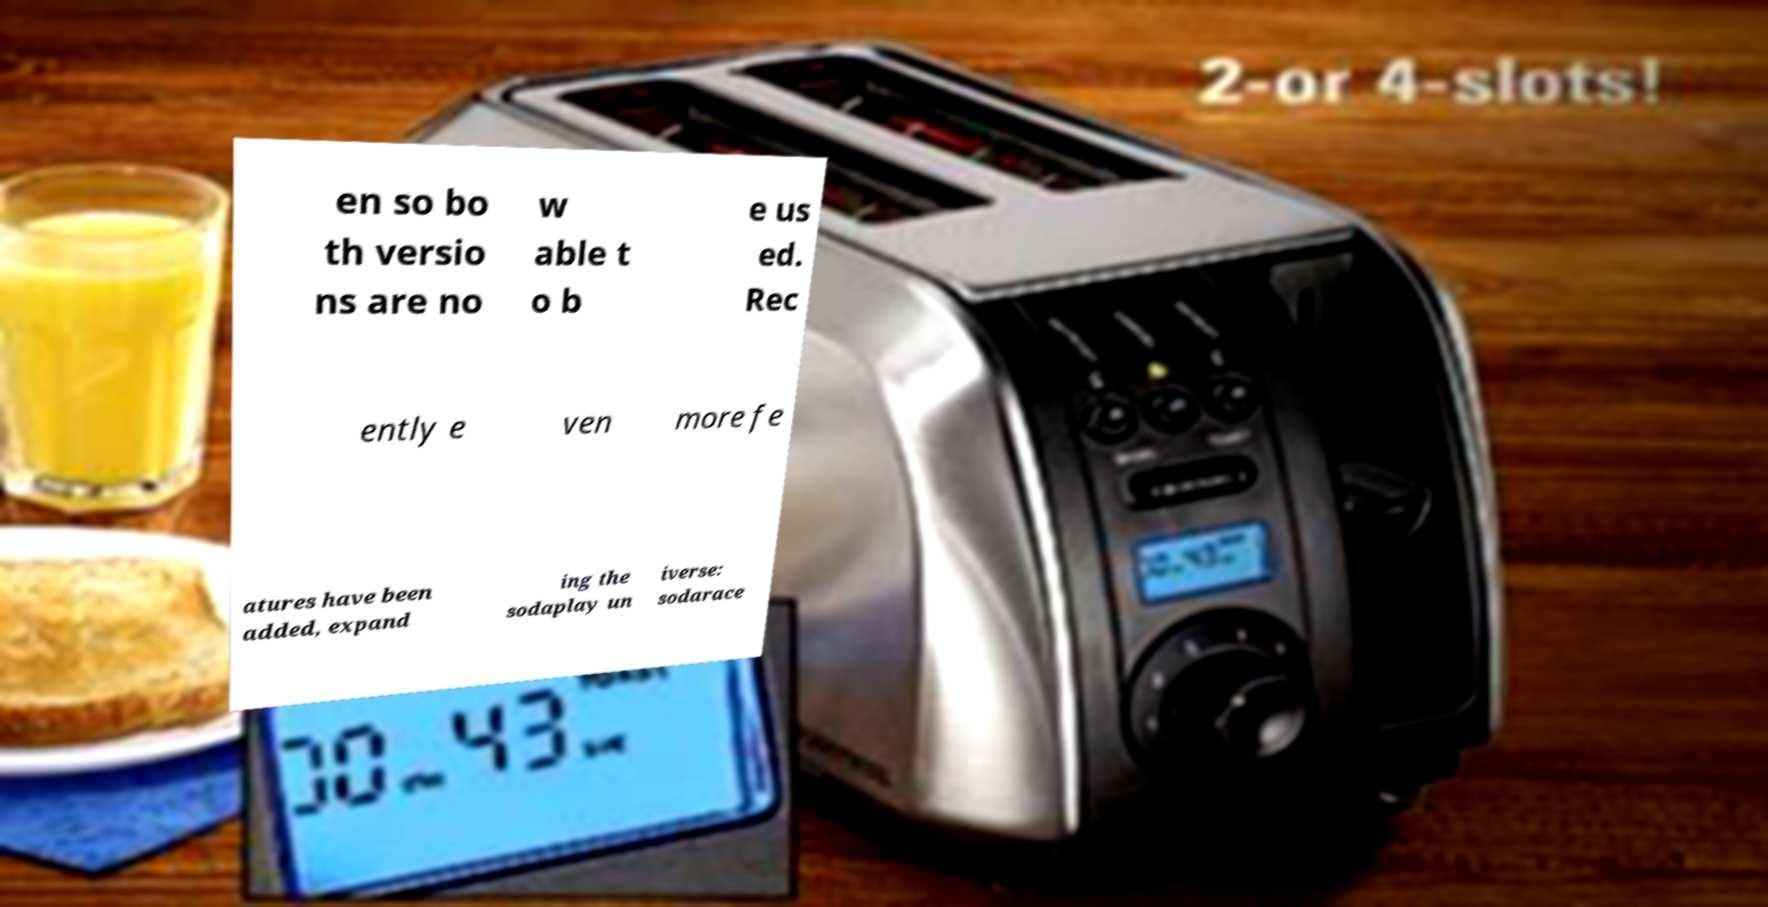Please identify and transcribe the text found in this image. en so bo th versio ns are no w able t o b e us ed. Rec ently e ven more fe atures have been added, expand ing the sodaplay un iverse: sodarace 